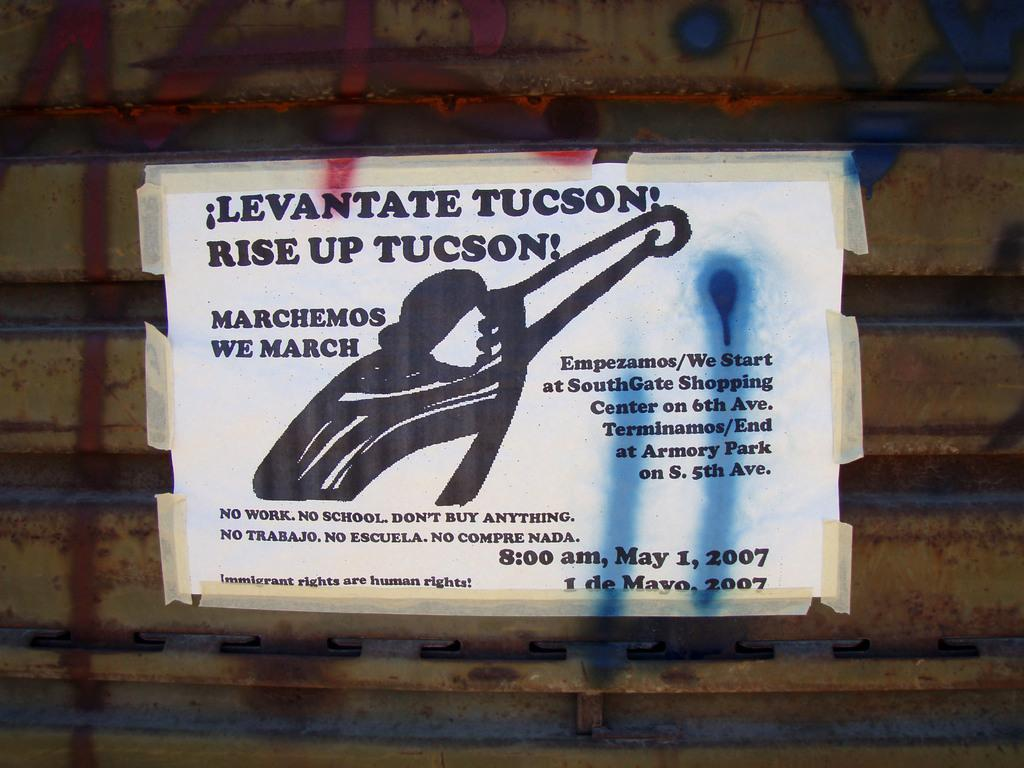What is present on a surface in the image? There is a poster on a surface in the image. What can be seen on the poster? There is an object depicted on the poster. Is there any text on the poster? Yes, there is text on the poster. What type of ornament is hanging from the ceiling in the image? There is no ornament hanging from the ceiling in the image; the main subject is the poster. Can you tell me how many people are taking a bath in the image? There is no scene of people taking a bath in the image; it features a poster with an object and text. 